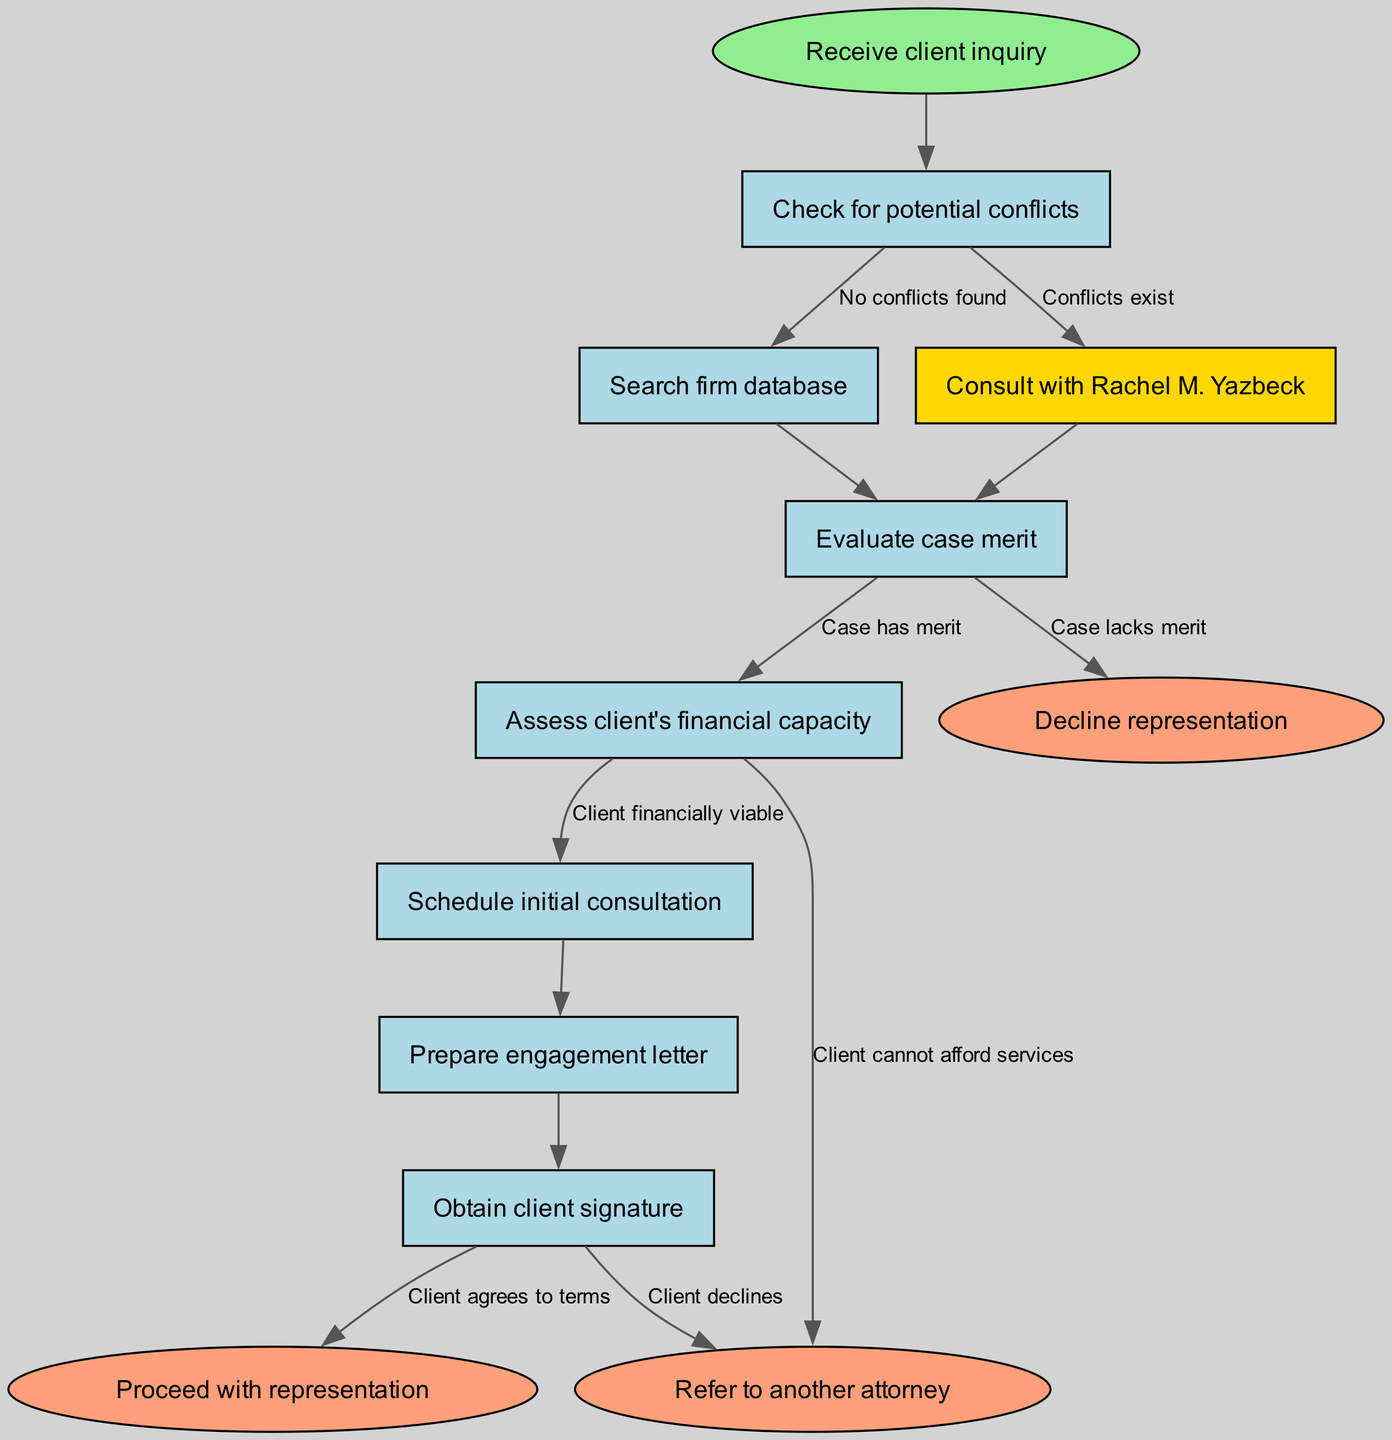What is the start node of the diagram? The start node of the diagram is labeled as "Receive client inquiry," which is indicated as the first point in the flowchart.
Answer: Receive client inquiry How many nodes are present in the diagram? The diagram consists of a total of 8 nodes, including the start and end nodes. The nodes include the start node and six process nodes, as well as three end nodes.
Answer: 8 What is the outcome if conflicts exist? If conflicts exist (indicated by the edge from "Check for potential conflicts" to "Consult with Rachel M. Yazbeck"), the next step in the flowchart leads to consulting Rachel M. Yazbeck.
Answer: Consult with Rachel M. Yazbeck What happens if the case has no merit? If the case lacks merit (as shown by the edge from "Evaluate case merit"), this leads to the end node where representation is declined.
Answer: Decline representation What step follows after assessing the client's financial capacity if they are financially viable? After assessing the client’s financial capacity and finding them financially viable, the next step in the flow is to schedule an initial consultation.
Answer: Schedule initial consultation What is the significance of the node that mentions Rachel M. Yazbeck? The node that mentions Rachel M. Yazbeck indicates a specific consultation step, which is highlighted in the diagram, and shows her importance in the conflict check process.
Answer: Significant consultation step How many edges are there leading from the "Evaluate case merit" node? The "Evaluate case merit" node has two edges leading from it; one leads to the outcome of proceeding with representation, and the other leads to declining representation if the case lacks merit.
Answer: 2 What final outcomes are possible based on the diagram? The final outcomes indicated in the diagram are "Proceed with representation," "Decline representation," and "Refer to another attorney," showing different paths based on prior evaluations.
Answer: Proceed with representation, Decline representation, Refer to another attorney What is the action taken if the client declines the terms? If the client declines the terms after the engagement letter is prepared, the flow ends at the node indicating the decline of representation.
Answer: Decline representation 